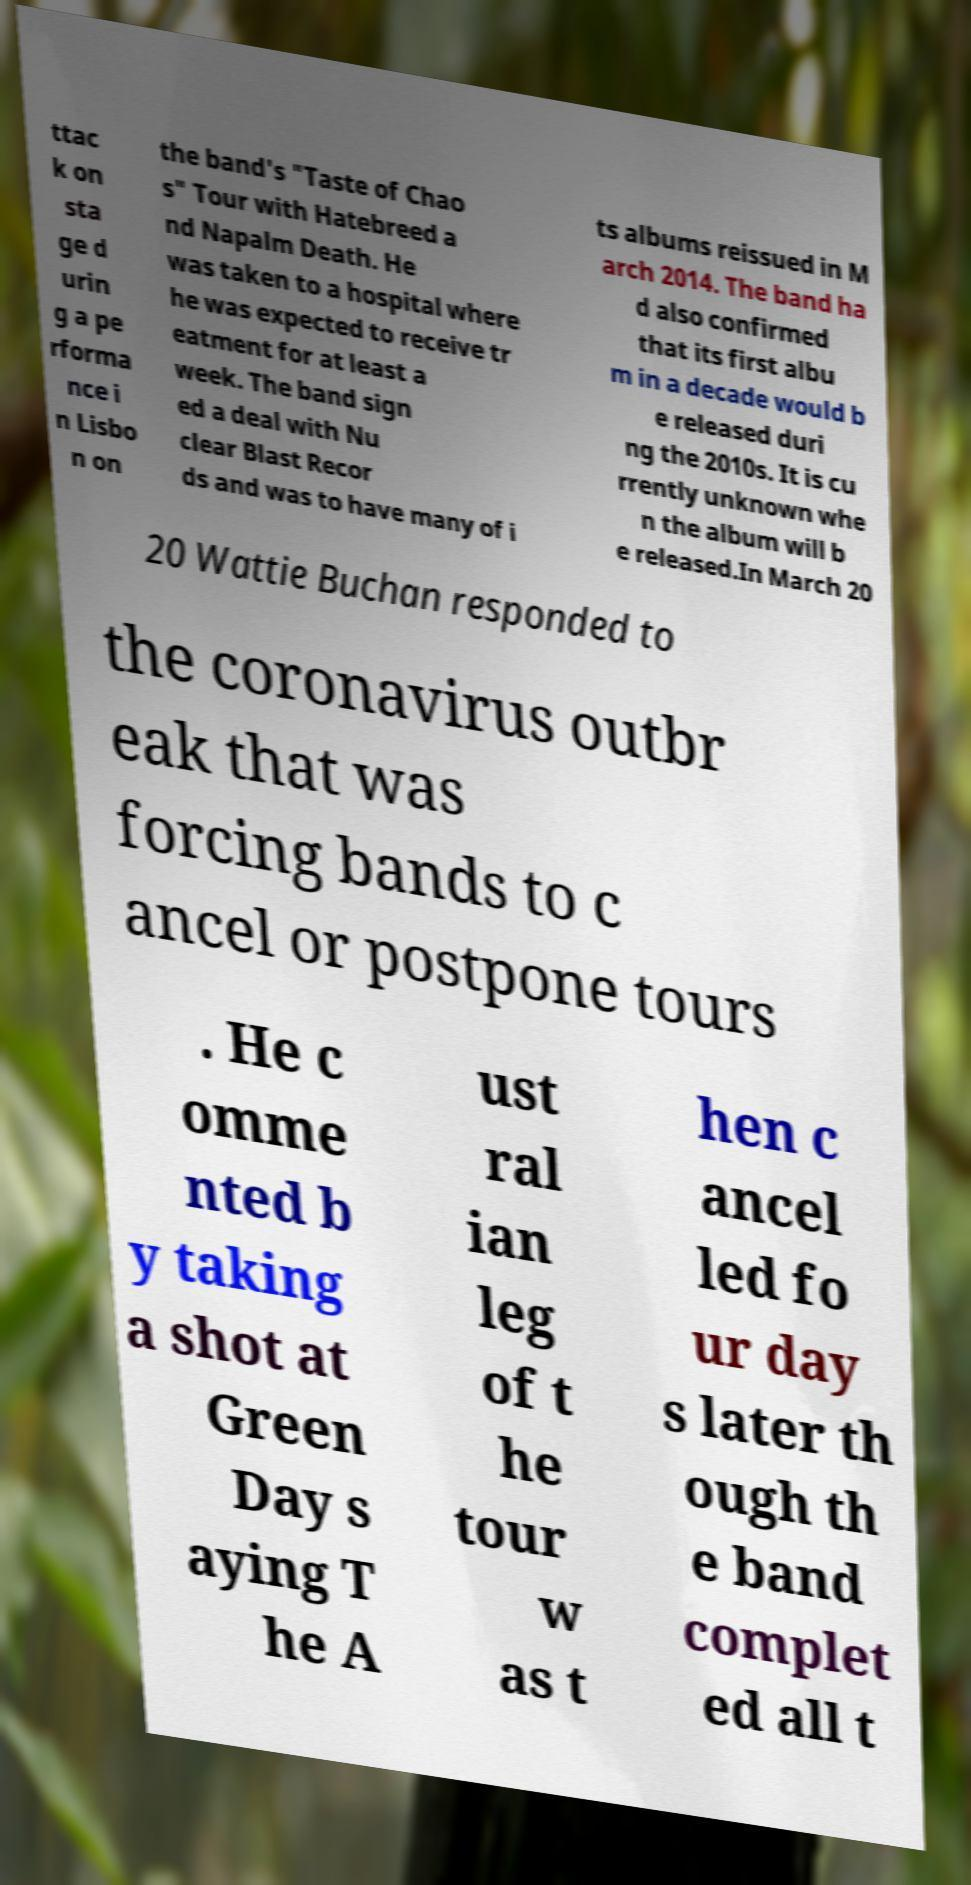There's text embedded in this image that I need extracted. Can you transcribe it verbatim? ttac k on sta ge d urin g a pe rforma nce i n Lisbo n on the band's "Taste of Chao s" Tour with Hatebreed a nd Napalm Death. He was taken to a hospital where he was expected to receive tr eatment for at least a week. The band sign ed a deal with Nu clear Blast Recor ds and was to have many of i ts albums reissued in M arch 2014. The band ha d also confirmed that its first albu m in a decade would b e released duri ng the 2010s. It is cu rrently unknown whe n the album will b e released.In March 20 20 Wattie Buchan responded to the coronavirus outbr eak that was forcing bands to c ancel or postpone tours . He c omme nted b y taking a shot at Green Day s aying T he A ust ral ian leg of t he tour w as t hen c ancel led fo ur day s later th ough th e band complet ed all t 